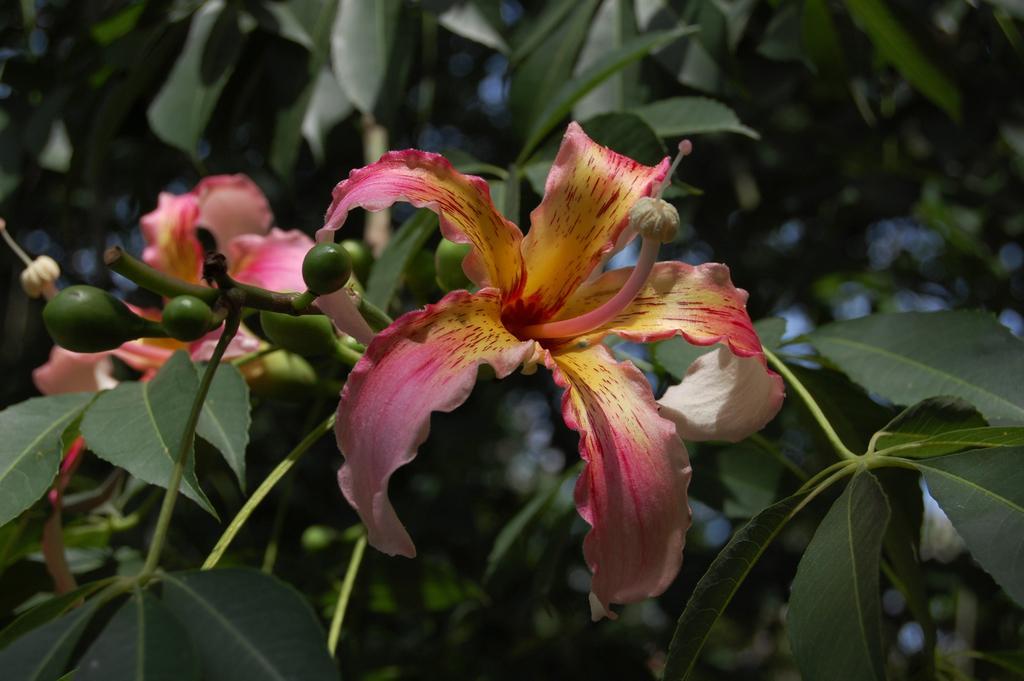Please provide a concise description of this image. In this image we can see some flowers which are in pink and yellow color and in the background of the image there are some leaves which are in green color. 